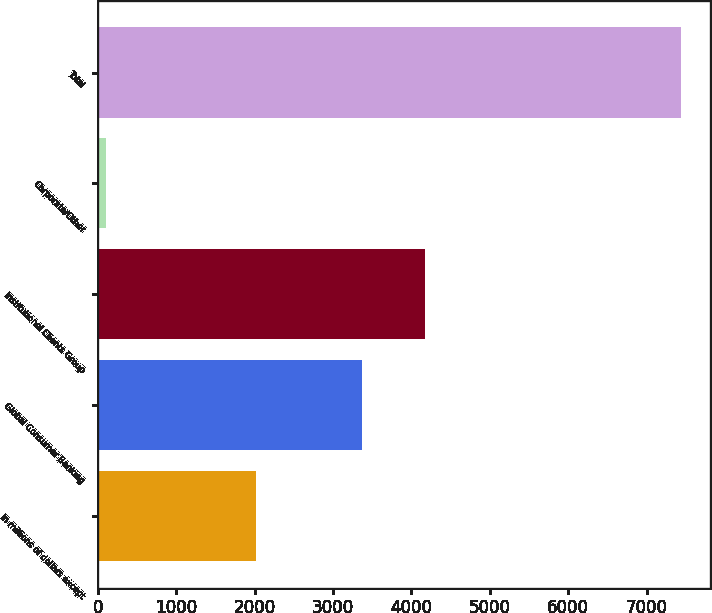<chart> <loc_0><loc_0><loc_500><loc_500><bar_chart><fcel>In millions of dollars except<fcel>Global Consumer Banking<fcel>Institutional Clients Group<fcel>Corporate/Other<fcel>Total<nl><fcel>2015<fcel>3369<fcel>4173<fcel>102<fcel>7440<nl></chart> 